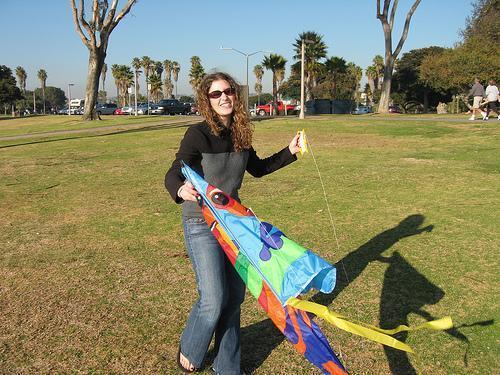How many kites are pictured?
Give a very brief answer. 1. 